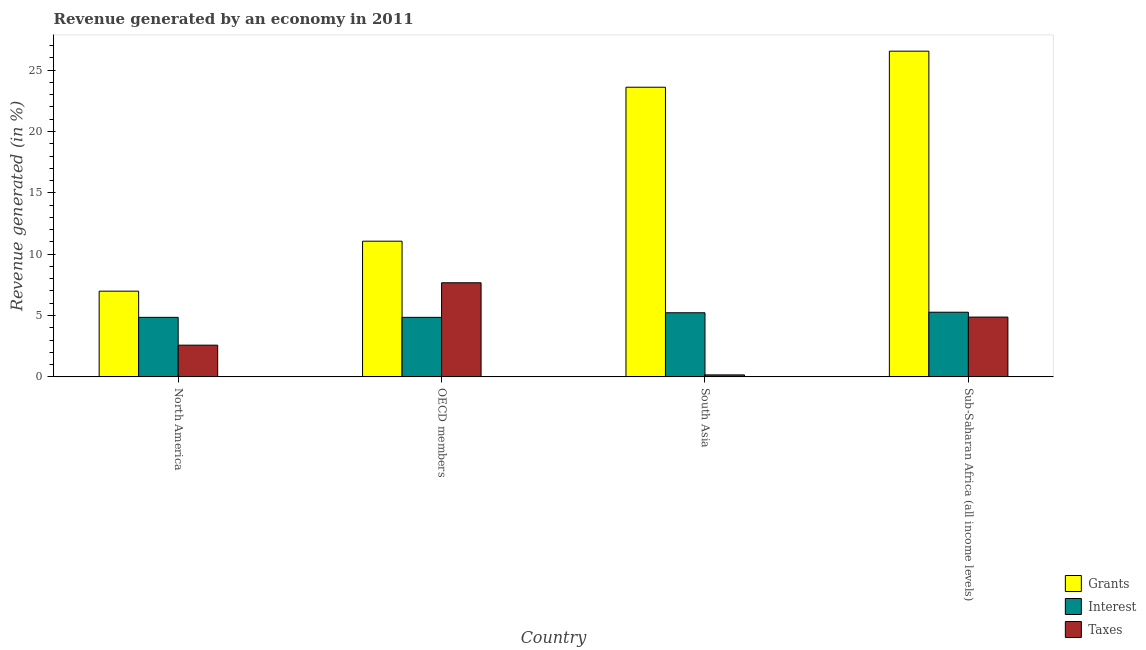How many different coloured bars are there?
Offer a terse response. 3. In how many cases, is the number of bars for a given country not equal to the number of legend labels?
Offer a terse response. 0. What is the percentage of revenue generated by interest in OECD members?
Ensure brevity in your answer.  4.85. Across all countries, what is the maximum percentage of revenue generated by grants?
Provide a succinct answer. 26.54. Across all countries, what is the minimum percentage of revenue generated by grants?
Offer a very short reply. 6.99. In which country was the percentage of revenue generated by interest minimum?
Offer a terse response. North America. What is the total percentage of revenue generated by interest in the graph?
Make the answer very short. 20.19. What is the difference between the percentage of revenue generated by taxes in OECD members and that in South Asia?
Provide a short and direct response. 7.51. What is the difference between the percentage of revenue generated by grants in Sub-Saharan Africa (all income levels) and the percentage of revenue generated by taxes in South Asia?
Give a very brief answer. 26.38. What is the average percentage of revenue generated by taxes per country?
Keep it short and to the point. 3.82. What is the difference between the percentage of revenue generated by interest and percentage of revenue generated by grants in North America?
Your answer should be compact. -2.13. What is the ratio of the percentage of revenue generated by taxes in North America to that in Sub-Saharan Africa (all income levels)?
Ensure brevity in your answer.  0.53. What is the difference between the highest and the second highest percentage of revenue generated by grants?
Provide a short and direct response. 2.94. What is the difference between the highest and the lowest percentage of revenue generated by interest?
Keep it short and to the point. 0.42. In how many countries, is the percentage of revenue generated by grants greater than the average percentage of revenue generated by grants taken over all countries?
Provide a succinct answer. 2. What does the 3rd bar from the left in Sub-Saharan Africa (all income levels) represents?
Offer a terse response. Taxes. What does the 1st bar from the right in OECD members represents?
Give a very brief answer. Taxes. How many bars are there?
Provide a short and direct response. 12. Are all the bars in the graph horizontal?
Give a very brief answer. No. Are the values on the major ticks of Y-axis written in scientific E-notation?
Make the answer very short. No. Does the graph contain grids?
Your answer should be very brief. No. Where does the legend appear in the graph?
Offer a terse response. Bottom right. What is the title of the graph?
Keep it short and to the point. Revenue generated by an economy in 2011. What is the label or title of the X-axis?
Your answer should be very brief. Country. What is the label or title of the Y-axis?
Keep it short and to the point. Revenue generated (in %). What is the Revenue generated (in %) of Grants in North America?
Offer a terse response. 6.99. What is the Revenue generated (in %) of Interest in North America?
Make the answer very short. 4.85. What is the Revenue generated (in %) of Taxes in North America?
Your answer should be compact. 2.58. What is the Revenue generated (in %) in Grants in OECD members?
Your answer should be compact. 11.06. What is the Revenue generated (in %) in Interest in OECD members?
Offer a terse response. 4.85. What is the Revenue generated (in %) of Taxes in OECD members?
Your answer should be compact. 7.67. What is the Revenue generated (in %) of Grants in South Asia?
Keep it short and to the point. 23.6. What is the Revenue generated (in %) in Interest in South Asia?
Ensure brevity in your answer.  5.22. What is the Revenue generated (in %) in Taxes in South Asia?
Offer a terse response. 0.16. What is the Revenue generated (in %) in Grants in Sub-Saharan Africa (all income levels)?
Offer a very short reply. 26.54. What is the Revenue generated (in %) in Interest in Sub-Saharan Africa (all income levels)?
Keep it short and to the point. 5.27. What is the Revenue generated (in %) of Taxes in Sub-Saharan Africa (all income levels)?
Offer a very short reply. 4.87. Across all countries, what is the maximum Revenue generated (in %) of Grants?
Ensure brevity in your answer.  26.54. Across all countries, what is the maximum Revenue generated (in %) in Interest?
Give a very brief answer. 5.27. Across all countries, what is the maximum Revenue generated (in %) of Taxes?
Give a very brief answer. 7.67. Across all countries, what is the minimum Revenue generated (in %) of Grants?
Ensure brevity in your answer.  6.99. Across all countries, what is the minimum Revenue generated (in %) in Interest?
Keep it short and to the point. 4.85. Across all countries, what is the minimum Revenue generated (in %) of Taxes?
Offer a very short reply. 0.16. What is the total Revenue generated (in %) of Grants in the graph?
Give a very brief answer. 68.19. What is the total Revenue generated (in %) in Interest in the graph?
Keep it short and to the point. 20.19. What is the total Revenue generated (in %) of Taxes in the graph?
Ensure brevity in your answer.  15.29. What is the difference between the Revenue generated (in %) in Grants in North America and that in OECD members?
Your answer should be very brief. -4.07. What is the difference between the Revenue generated (in %) of Interest in North America and that in OECD members?
Give a very brief answer. 0. What is the difference between the Revenue generated (in %) of Taxes in North America and that in OECD members?
Offer a terse response. -5.08. What is the difference between the Revenue generated (in %) in Grants in North America and that in South Asia?
Keep it short and to the point. -16.62. What is the difference between the Revenue generated (in %) of Interest in North America and that in South Asia?
Give a very brief answer. -0.37. What is the difference between the Revenue generated (in %) of Taxes in North America and that in South Asia?
Your answer should be compact. 2.42. What is the difference between the Revenue generated (in %) of Grants in North America and that in Sub-Saharan Africa (all income levels)?
Your answer should be compact. -19.56. What is the difference between the Revenue generated (in %) in Interest in North America and that in Sub-Saharan Africa (all income levels)?
Keep it short and to the point. -0.42. What is the difference between the Revenue generated (in %) in Taxes in North America and that in Sub-Saharan Africa (all income levels)?
Offer a very short reply. -2.29. What is the difference between the Revenue generated (in %) of Grants in OECD members and that in South Asia?
Give a very brief answer. -12.55. What is the difference between the Revenue generated (in %) of Interest in OECD members and that in South Asia?
Your response must be concise. -0.37. What is the difference between the Revenue generated (in %) in Taxes in OECD members and that in South Asia?
Your answer should be very brief. 7.51. What is the difference between the Revenue generated (in %) of Grants in OECD members and that in Sub-Saharan Africa (all income levels)?
Offer a terse response. -15.49. What is the difference between the Revenue generated (in %) in Interest in OECD members and that in Sub-Saharan Africa (all income levels)?
Provide a succinct answer. -0.42. What is the difference between the Revenue generated (in %) in Taxes in OECD members and that in Sub-Saharan Africa (all income levels)?
Give a very brief answer. 2.8. What is the difference between the Revenue generated (in %) of Grants in South Asia and that in Sub-Saharan Africa (all income levels)?
Offer a terse response. -2.94. What is the difference between the Revenue generated (in %) in Interest in South Asia and that in Sub-Saharan Africa (all income levels)?
Make the answer very short. -0.04. What is the difference between the Revenue generated (in %) in Taxes in South Asia and that in Sub-Saharan Africa (all income levels)?
Provide a short and direct response. -4.71. What is the difference between the Revenue generated (in %) in Grants in North America and the Revenue generated (in %) in Interest in OECD members?
Keep it short and to the point. 2.13. What is the difference between the Revenue generated (in %) in Grants in North America and the Revenue generated (in %) in Taxes in OECD members?
Offer a terse response. -0.68. What is the difference between the Revenue generated (in %) in Interest in North America and the Revenue generated (in %) in Taxes in OECD members?
Your answer should be compact. -2.82. What is the difference between the Revenue generated (in %) in Grants in North America and the Revenue generated (in %) in Interest in South Asia?
Give a very brief answer. 1.76. What is the difference between the Revenue generated (in %) in Grants in North America and the Revenue generated (in %) in Taxes in South Asia?
Make the answer very short. 6.82. What is the difference between the Revenue generated (in %) in Interest in North America and the Revenue generated (in %) in Taxes in South Asia?
Provide a short and direct response. 4.69. What is the difference between the Revenue generated (in %) in Grants in North America and the Revenue generated (in %) in Interest in Sub-Saharan Africa (all income levels)?
Give a very brief answer. 1.72. What is the difference between the Revenue generated (in %) in Grants in North America and the Revenue generated (in %) in Taxes in Sub-Saharan Africa (all income levels)?
Keep it short and to the point. 2.11. What is the difference between the Revenue generated (in %) in Interest in North America and the Revenue generated (in %) in Taxes in Sub-Saharan Africa (all income levels)?
Provide a succinct answer. -0.02. What is the difference between the Revenue generated (in %) in Grants in OECD members and the Revenue generated (in %) in Interest in South Asia?
Make the answer very short. 5.83. What is the difference between the Revenue generated (in %) of Grants in OECD members and the Revenue generated (in %) of Taxes in South Asia?
Make the answer very short. 10.9. What is the difference between the Revenue generated (in %) of Interest in OECD members and the Revenue generated (in %) of Taxes in South Asia?
Keep it short and to the point. 4.69. What is the difference between the Revenue generated (in %) in Grants in OECD members and the Revenue generated (in %) in Interest in Sub-Saharan Africa (all income levels)?
Ensure brevity in your answer.  5.79. What is the difference between the Revenue generated (in %) of Grants in OECD members and the Revenue generated (in %) of Taxes in Sub-Saharan Africa (all income levels)?
Ensure brevity in your answer.  6.18. What is the difference between the Revenue generated (in %) of Interest in OECD members and the Revenue generated (in %) of Taxes in Sub-Saharan Africa (all income levels)?
Give a very brief answer. -0.02. What is the difference between the Revenue generated (in %) of Grants in South Asia and the Revenue generated (in %) of Interest in Sub-Saharan Africa (all income levels)?
Your answer should be compact. 18.34. What is the difference between the Revenue generated (in %) of Grants in South Asia and the Revenue generated (in %) of Taxes in Sub-Saharan Africa (all income levels)?
Provide a short and direct response. 18.73. What is the difference between the Revenue generated (in %) in Interest in South Asia and the Revenue generated (in %) in Taxes in Sub-Saharan Africa (all income levels)?
Provide a short and direct response. 0.35. What is the average Revenue generated (in %) in Grants per country?
Make the answer very short. 17.05. What is the average Revenue generated (in %) in Interest per country?
Offer a very short reply. 5.05. What is the average Revenue generated (in %) in Taxes per country?
Provide a short and direct response. 3.82. What is the difference between the Revenue generated (in %) of Grants and Revenue generated (in %) of Interest in North America?
Your response must be concise. 2.13. What is the difference between the Revenue generated (in %) in Grants and Revenue generated (in %) in Taxes in North America?
Your response must be concise. 4.4. What is the difference between the Revenue generated (in %) in Interest and Revenue generated (in %) in Taxes in North America?
Your answer should be compact. 2.27. What is the difference between the Revenue generated (in %) of Grants and Revenue generated (in %) of Interest in OECD members?
Ensure brevity in your answer.  6.21. What is the difference between the Revenue generated (in %) of Grants and Revenue generated (in %) of Taxes in OECD members?
Give a very brief answer. 3.39. What is the difference between the Revenue generated (in %) of Interest and Revenue generated (in %) of Taxes in OECD members?
Provide a short and direct response. -2.82. What is the difference between the Revenue generated (in %) in Grants and Revenue generated (in %) in Interest in South Asia?
Your answer should be compact. 18.38. What is the difference between the Revenue generated (in %) in Grants and Revenue generated (in %) in Taxes in South Asia?
Give a very brief answer. 23.44. What is the difference between the Revenue generated (in %) of Interest and Revenue generated (in %) of Taxes in South Asia?
Ensure brevity in your answer.  5.06. What is the difference between the Revenue generated (in %) of Grants and Revenue generated (in %) of Interest in Sub-Saharan Africa (all income levels)?
Ensure brevity in your answer.  21.28. What is the difference between the Revenue generated (in %) in Grants and Revenue generated (in %) in Taxes in Sub-Saharan Africa (all income levels)?
Provide a succinct answer. 21.67. What is the difference between the Revenue generated (in %) in Interest and Revenue generated (in %) in Taxes in Sub-Saharan Africa (all income levels)?
Ensure brevity in your answer.  0.4. What is the ratio of the Revenue generated (in %) in Grants in North America to that in OECD members?
Keep it short and to the point. 0.63. What is the ratio of the Revenue generated (in %) of Interest in North America to that in OECD members?
Your response must be concise. 1. What is the ratio of the Revenue generated (in %) in Taxes in North America to that in OECD members?
Provide a short and direct response. 0.34. What is the ratio of the Revenue generated (in %) in Grants in North America to that in South Asia?
Keep it short and to the point. 0.3. What is the ratio of the Revenue generated (in %) in Interest in North America to that in South Asia?
Provide a succinct answer. 0.93. What is the ratio of the Revenue generated (in %) in Taxes in North America to that in South Asia?
Provide a succinct answer. 16.06. What is the ratio of the Revenue generated (in %) of Grants in North America to that in Sub-Saharan Africa (all income levels)?
Provide a succinct answer. 0.26. What is the ratio of the Revenue generated (in %) of Interest in North America to that in Sub-Saharan Africa (all income levels)?
Make the answer very short. 0.92. What is the ratio of the Revenue generated (in %) in Taxes in North America to that in Sub-Saharan Africa (all income levels)?
Your answer should be very brief. 0.53. What is the ratio of the Revenue generated (in %) in Grants in OECD members to that in South Asia?
Make the answer very short. 0.47. What is the ratio of the Revenue generated (in %) in Interest in OECD members to that in South Asia?
Ensure brevity in your answer.  0.93. What is the ratio of the Revenue generated (in %) in Taxes in OECD members to that in South Asia?
Provide a short and direct response. 47.67. What is the ratio of the Revenue generated (in %) of Grants in OECD members to that in Sub-Saharan Africa (all income levels)?
Offer a very short reply. 0.42. What is the ratio of the Revenue generated (in %) of Interest in OECD members to that in Sub-Saharan Africa (all income levels)?
Give a very brief answer. 0.92. What is the ratio of the Revenue generated (in %) of Taxes in OECD members to that in Sub-Saharan Africa (all income levels)?
Your response must be concise. 1.57. What is the ratio of the Revenue generated (in %) of Grants in South Asia to that in Sub-Saharan Africa (all income levels)?
Provide a succinct answer. 0.89. What is the ratio of the Revenue generated (in %) in Interest in South Asia to that in Sub-Saharan Africa (all income levels)?
Provide a short and direct response. 0.99. What is the ratio of the Revenue generated (in %) of Taxes in South Asia to that in Sub-Saharan Africa (all income levels)?
Your answer should be compact. 0.03. What is the difference between the highest and the second highest Revenue generated (in %) in Grants?
Provide a succinct answer. 2.94. What is the difference between the highest and the second highest Revenue generated (in %) in Interest?
Keep it short and to the point. 0.04. What is the difference between the highest and the second highest Revenue generated (in %) of Taxes?
Offer a terse response. 2.8. What is the difference between the highest and the lowest Revenue generated (in %) of Grants?
Your answer should be compact. 19.56. What is the difference between the highest and the lowest Revenue generated (in %) in Interest?
Your response must be concise. 0.42. What is the difference between the highest and the lowest Revenue generated (in %) of Taxes?
Your answer should be very brief. 7.51. 